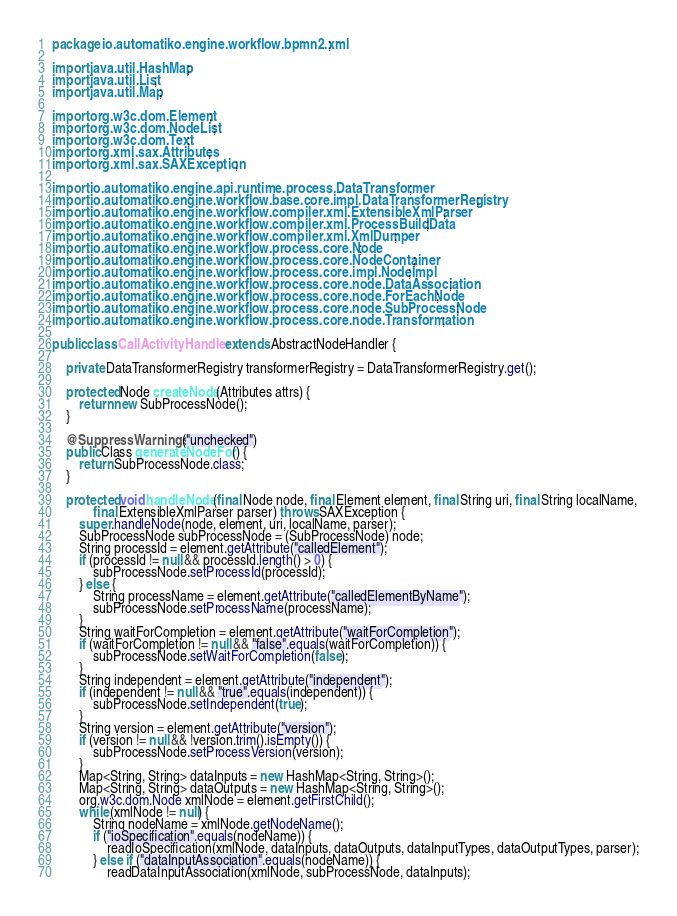<code> <loc_0><loc_0><loc_500><loc_500><_Java_>
package io.automatiko.engine.workflow.bpmn2.xml;

import java.util.HashMap;
import java.util.List;
import java.util.Map;

import org.w3c.dom.Element;
import org.w3c.dom.NodeList;
import org.w3c.dom.Text;
import org.xml.sax.Attributes;
import org.xml.sax.SAXException;

import io.automatiko.engine.api.runtime.process.DataTransformer;
import io.automatiko.engine.workflow.base.core.impl.DataTransformerRegistry;
import io.automatiko.engine.workflow.compiler.xml.ExtensibleXmlParser;
import io.automatiko.engine.workflow.compiler.xml.ProcessBuildData;
import io.automatiko.engine.workflow.compiler.xml.XmlDumper;
import io.automatiko.engine.workflow.process.core.Node;
import io.automatiko.engine.workflow.process.core.NodeContainer;
import io.automatiko.engine.workflow.process.core.impl.NodeImpl;
import io.automatiko.engine.workflow.process.core.node.DataAssociation;
import io.automatiko.engine.workflow.process.core.node.ForEachNode;
import io.automatiko.engine.workflow.process.core.node.SubProcessNode;
import io.automatiko.engine.workflow.process.core.node.Transformation;

public class CallActivityHandler extends AbstractNodeHandler {

    private DataTransformerRegistry transformerRegistry = DataTransformerRegistry.get();

    protected Node createNode(Attributes attrs) {
        return new SubProcessNode();
    }

    @SuppressWarnings("unchecked")
    public Class generateNodeFor() {
        return SubProcessNode.class;
    }

    protected void handleNode(final Node node, final Element element, final String uri, final String localName,
            final ExtensibleXmlParser parser) throws SAXException {
        super.handleNode(node, element, uri, localName, parser);
        SubProcessNode subProcessNode = (SubProcessNode) node;
        String processId = element.getAttribute("calledElement");
        if (processId != null && processId.length() > 0) {
            subProcessNode.setProcessId(processId);
        } else {
            String processName = element.getAttribute("calledElementByName");
            subProcessNode.setProcessName(processName);
        }
        String waitForCompletion = element.getAttribute("waitForCompletion");
        if (waitForCompletion != null && "false".equals(waitForCompletion)) {
            subProcessNode.setWaitForCompletion(false);
        }
        String independent = element.getAttribute("independent");
        if (independent != null && "true".equals(independent)) {
            subProcessNode.setIndependent(true);
        }
        String version = element.getAttribute("version");
        if (version != null && !version.trim().isEmpty()) {
            subProcessNode.setProcessVersion(version);
        }
        Map<String, String> dataInputs = new HashMap<String, String>();
        Map<String, String> dataOutputs = new HashMap<String, String>();
        org.w3c.dom.Node xmlNode = element.getFirstChild();
        while (xmlNode != null) {
            String nodeName = xmlNode.getNodeName();
            if ("ioSpecification".equals(nodeName)) {
                readIoSpecification(xmlNode, dataInputs, dataOutputs, dataInputTypes, dataOutputTypes, parser);
            } else if ("dataInputAssociation".equals(nodeName)) {
                readDataInputAssociation(xmlNode, subProcessNode, dataInputs);</code> 